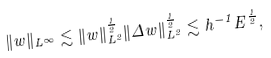Convert formula to latex. <formula><loc_0><loc_0><loc_500><loc_500>\| w \| _ { L ^ { \infty } } \lesssim \| w \| _ { L ^ { 2 } } ^ { \frac { 1 } { 2 } } \| \Delta w \| _ { L ^ { 2 } } ^ { \frac { 1 } { 2 } } \lesssim h ^ { - 1 } E ^ { \frac { 1 } { 2 } } ,</formula> 